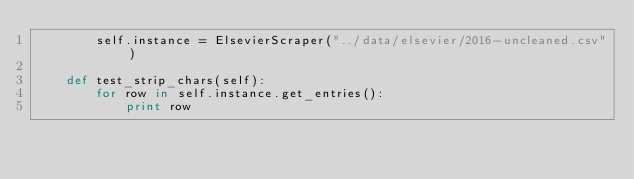<code> <loc_0><loc_0><loc_500><loc_500><_Python_>        self.instance = ElsevierScraper("../data/elsevier/2016-uncleaned.csv")

    def test_strip_chars(self):
        for row in self.instance.get_entries():
            print row
</code> 